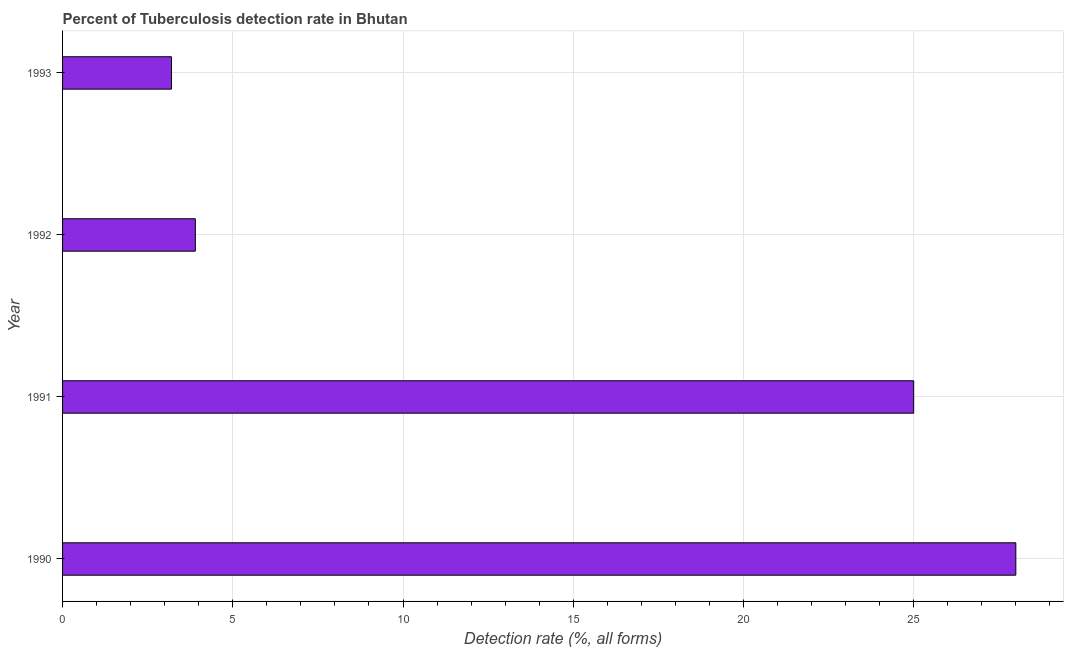Does the graph contain grids?
Your answer should be compact. Yes. What is the title of the graph?
Your response must be concise. Percent of Tuberculosis detection rate in Bhutan. What is the label or title of the X-axis?
Keep it short and to the point. Detection rate (%, all forms). What is the label or title of the Y-axis?
Keep it short and to the point. Year. In which year was the detection rate of tuberculosis maximum?
Keep it short and to the point. 1990. In which year was the detection rate of tuberculosis minimum?
Ensure brevity in your answer.  1993. What is the sum of the detection rate of tuberculosis?
Your response must be concise. 60.1. What is the difference between the detection rate of tuberculosis in 1992 and 1993?
Your answer should be compact. 0.7. What is the average detection rate of tuberculosis per year?
Your response must be concise. 15.03. What is the median detection rate of tuberculosis?
Make the answer very short. 14.45. In how many years, is the detection rate of tuberculosis greater than 21 %?
Give a very brief answer. 2. Do a majority of the years between 1990 and 1992 (inclusive) have detection rate of tuberculosis greater than 24 %?
Offer a terse response. Yes. What is the ratio of the detection rate of tuberculosis in 1992 to that in 1993?
Provide a succinct answer. 1.22. Is the difference between the detection rate of tuberculosis in 1990 and 1992 greater than the difference between any two years?
Provide a succinct answer. No. Is the sum of the detection rate of tuberculosis in 1990 and 1992 greater than the maximum detection rate of tuberculosis across all years?
Provide a succinct answer. Yes. What is the difference between the highest and the lowest detection rate of tuberculosis?
Your answer should be very brief. 24.8. Are all the bars in the graph horizontal?
Your response must be concise. Yes. How many years are there in the graph?
Your answer should be very brief. 4. Are the values on the major ticks of X-axis written in scientific E-notation?
Offer a very short reply. No. What is the Detection rate (%, all forms) in 1991?
Offer a terse response. 25. What is the Detection rate (%, all forms) of 1992?
Your answer should be very brief. 3.9. What is the difference between the Detection rate (%, all forms) in 1990 and 1991?
Give a very brief answer. 3. What is the difference between the Detection rate (%, all forms) in 1990 and 1992?
Keep it short and to the point. 24.1. What is the difference between the Detection rate (%, all forms) in 1990 and 1993?
Provide a succinct answer. 24.8. What is the difference between the Detection rate (%, all forms) in 1991 and 1992?
Your answer should be very brief. 21.1. What is the difference between the Detection rate (%, all forms) in 1991 and 1993?
Provide a succinct answer. 21.8. What is the ratio of the Detection rate (%, all forms) in 1990 to that in 1991?
Offer a very short reply. 1.12. What is the ratio of the Detection rate (%, all forms) in 1990 to that in 1992?
Provide a short and direct response. 7.18. What is the ratio of the Detection rate (%, all forms) in 1990 to that in 1993?
Your answer should be very brief. 8.75. What is the ratio of the Detection rate (%, all forms) in 1991 to that in 1992?
Your answer should be compact. 6.41. What is the ratio of the Detection rate (%, all forms) in 1991 to that in 1993?
Provide a succinct answer. 7.81. What is the ratio of the Detection rate (%, all forms) in 1992 to that in 1993?
Give a very brief answer. 1.22. 